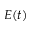Convert formula to latex. <formula><loc_0><loc_0><loc_500><loc_500>E ( t )</formula> 